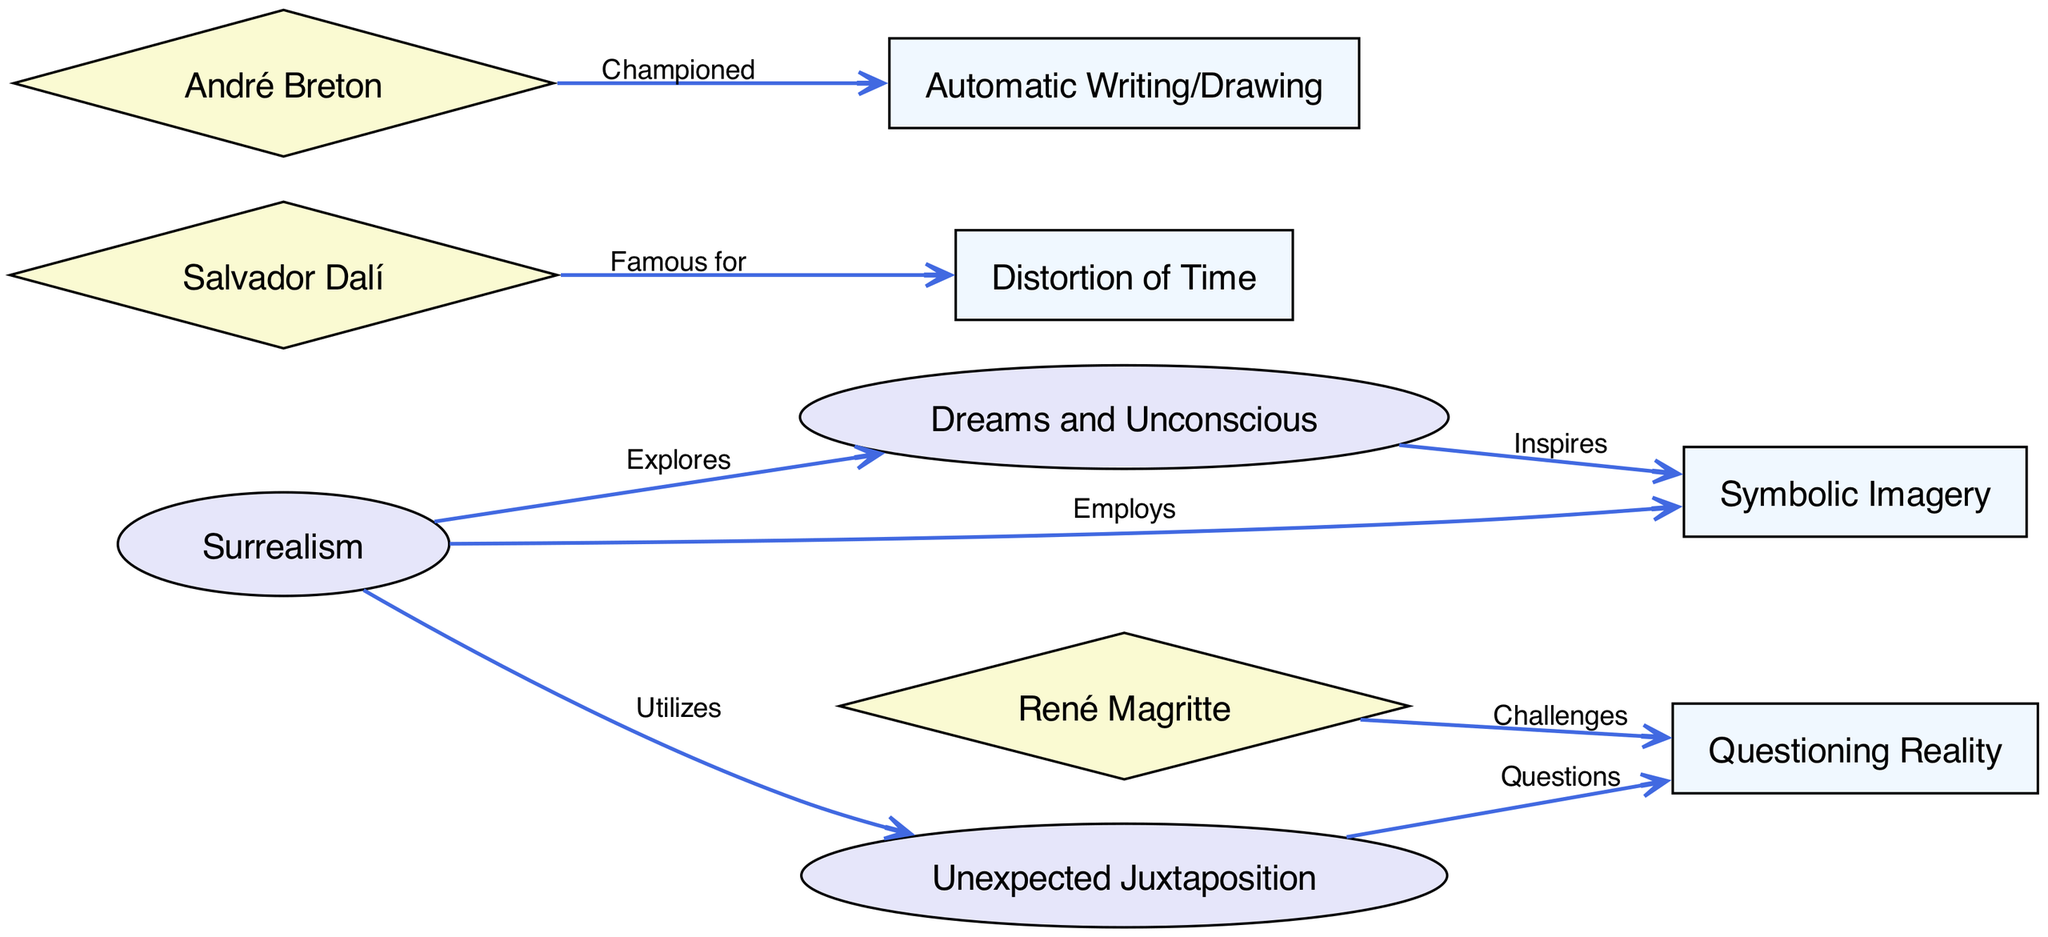What is the central theme of the diagram? The central theme depicted in the diagram is "Surrealism," as it is the main node from which other themes and concepts emanate.
Answer: Surrealism How many nodes are present in the diagram? By counting the unique nodes listed, we find there are 10 nodes in total.
Answer: 10 What element does Dalí's work famously distort? The diagram illustrates that Salvador Dalí is particularly associated with the "Distortion of Time," showcasing a key element of his surrealist style.
Answer: Time Which artist is noted for challenging reality? According to the diagram, René Magritte is specifically mentioned as the artist who "Challenges" reality, making him notable for this theme in his works.
Answer: René Magritte What relationship does "dreams" have with "symbolism"? The diagram states that "dreams" "Inspire" "symbolism," indicating that the concept of dreams is a source of inspiration for the symbolic imagery used in surrealism.
Answer: Inspires Which artist championed automatic writing? The diagram specifies that André Breton "Championed" automatic writing, highlighting his pivotal role in promoting this aspect of surrealism.
Answer: André Breton What thematic approach is utilized by surrealism alongside dreams? The diagram indicates that surrealism not only explores "dreams" but also "Utilizes" "Unexpected Juxtaposition," showing a dual approach in its thematic exploration.
Answer: Unexpected Juxtaposition How does "juxtaposition" relate to reality? The diagram shows that "juxtaposition" "Questions" "reality," illustrating how surrealist techniques challenge conventional perceptions of reality through unexpected combinations.
Answer: Questions What specific technique is linked to the idea of dreams inspiring symbolism? The connection indicated that "symbolism" is influenced by "dreams" within the surrealist context, which means dream imagery commonly informs the symbolic elements present in the art and poetry.
Answer: Symbolic Imagery 